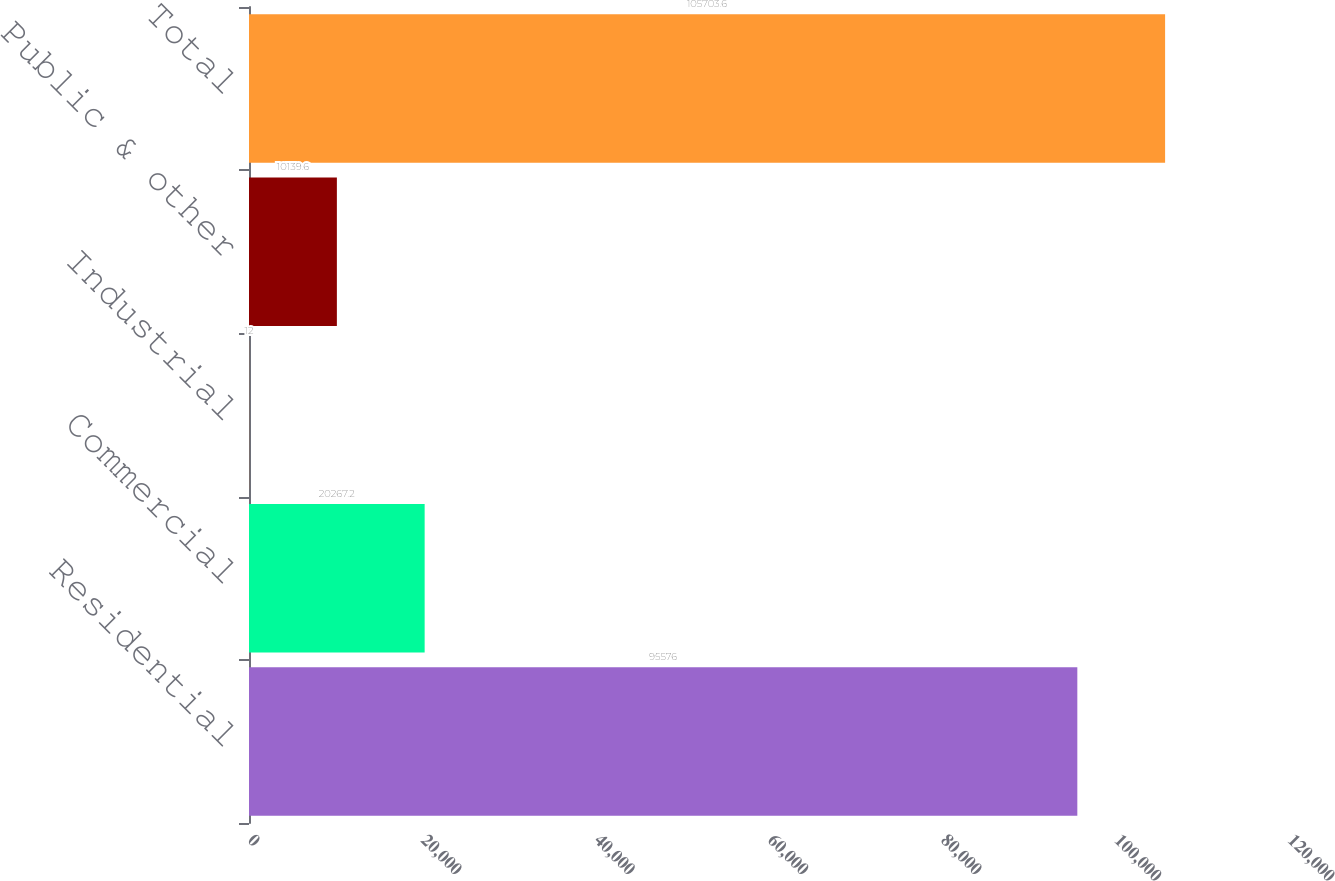Convert chart. <chart><loc_0><loc_0><loc_500><loc_500><bar_chart><fcel>Residential<fcel>Commercial<fcel>Industrial<fcel>Public & other<fcel>Total<nl><fcel>95576<fcel>20267.2<fcel>12<fcel>10139.6<fcel>105704<nl></chart> 